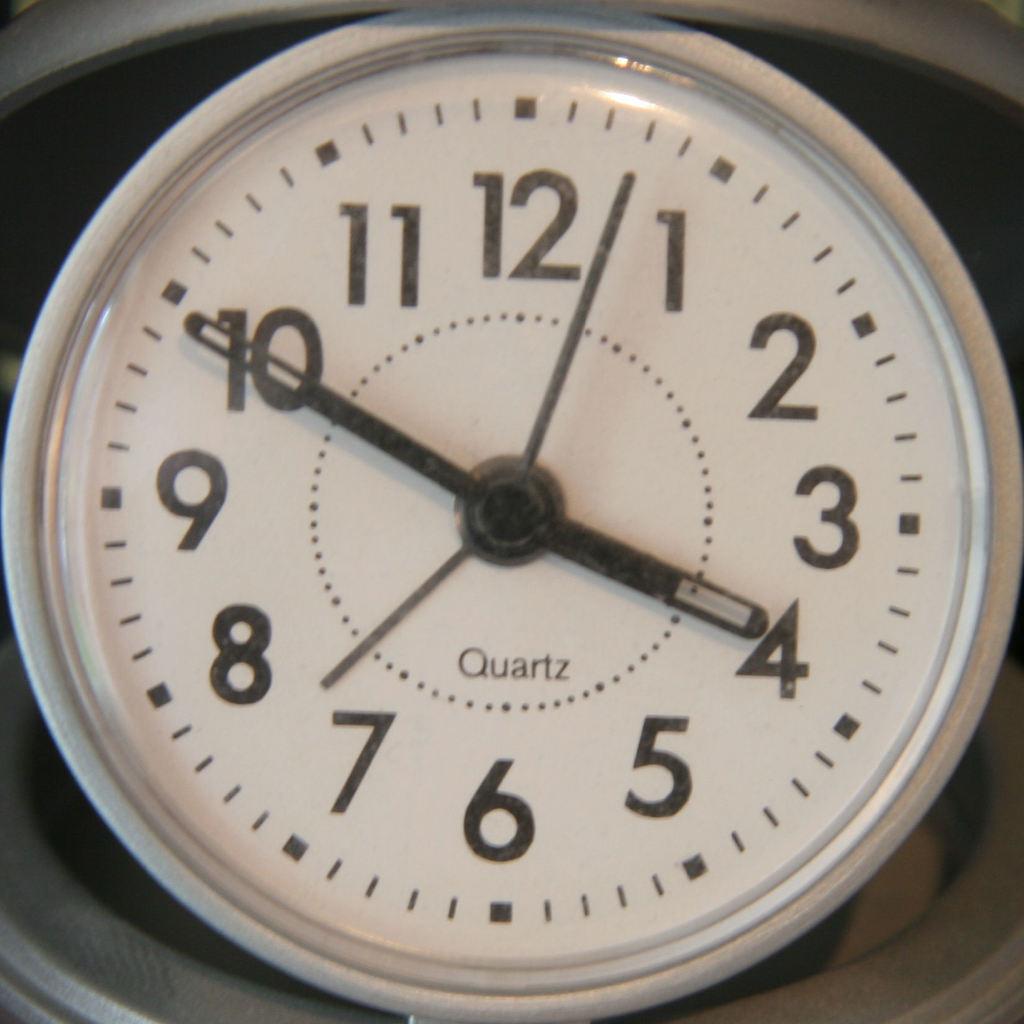What time is it?
Your response must be concise. 3:50. 